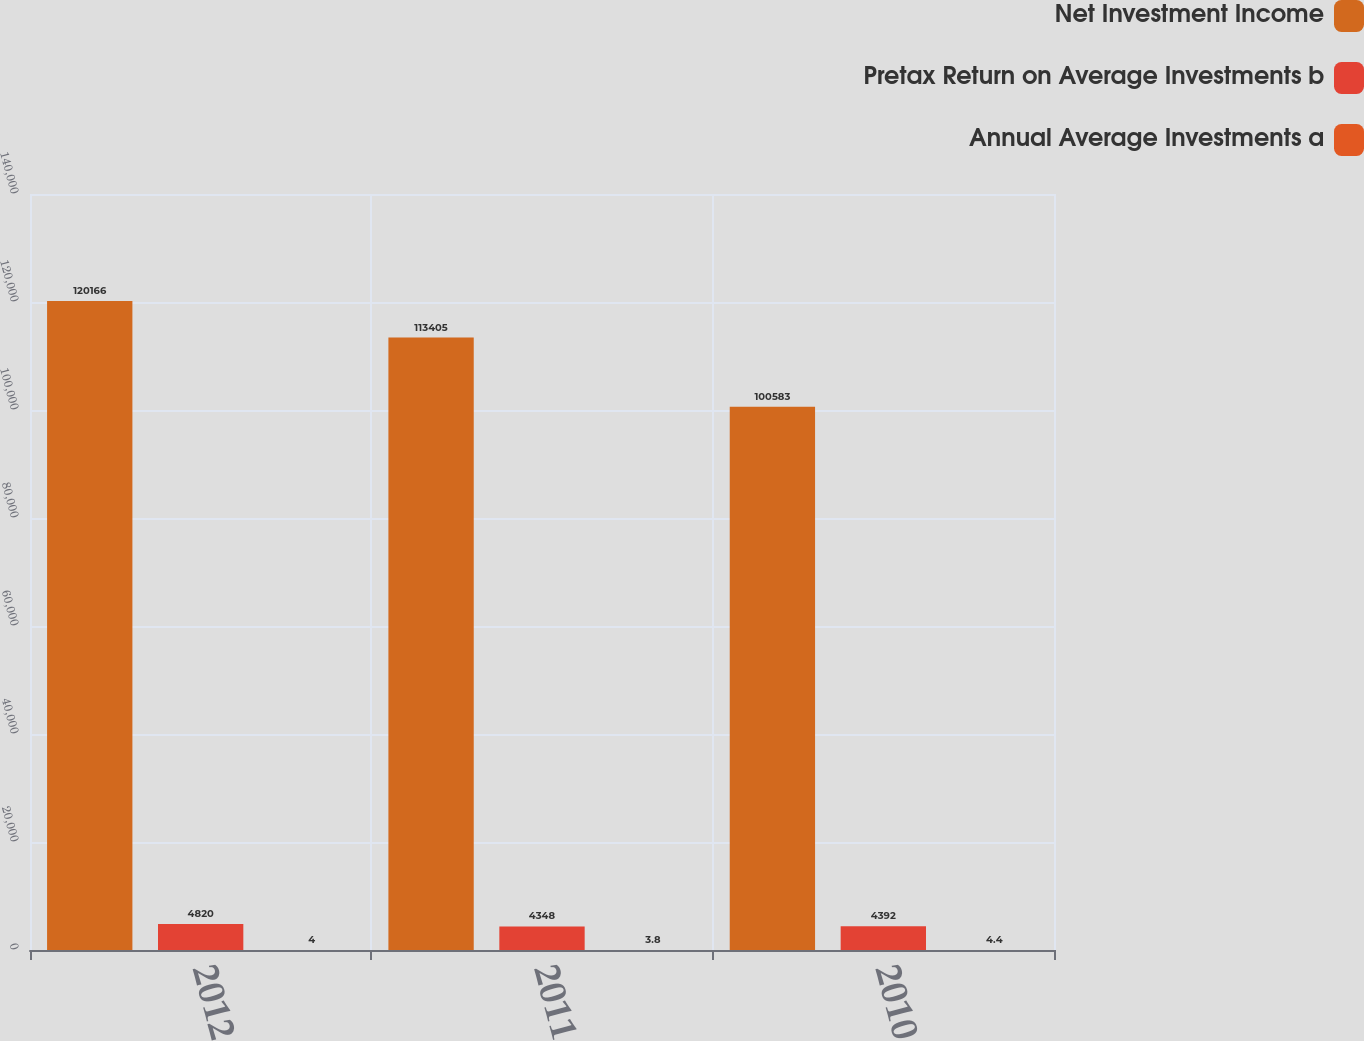<chart> <loc_0><loc_0><loc_500><loc_500><stacked_bar_chart><ecel><fcel>2012<fcel>2011<fcel>2010<nl><fcel>Net Investment Income<fcel>120166<fcel>113405<fcel>100583<nl><fcel>Pretax Return on Average Investments b<fcel>4820<fcel>4348<fcel>4392<nl><fcel>Annual Average Investments a<fcel>4<fcel>3.8<fcel>4.4<nl></chart> 